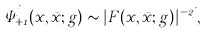<formula> <loc_0><loc_0><loc_500><loc_500>\Psi _ { + 1 } ^ { j } ( x , \bar { x } ; g ) \sim | F ( x , \bar { x } ; g ) | ^ { - 2 j } ,</formula> 